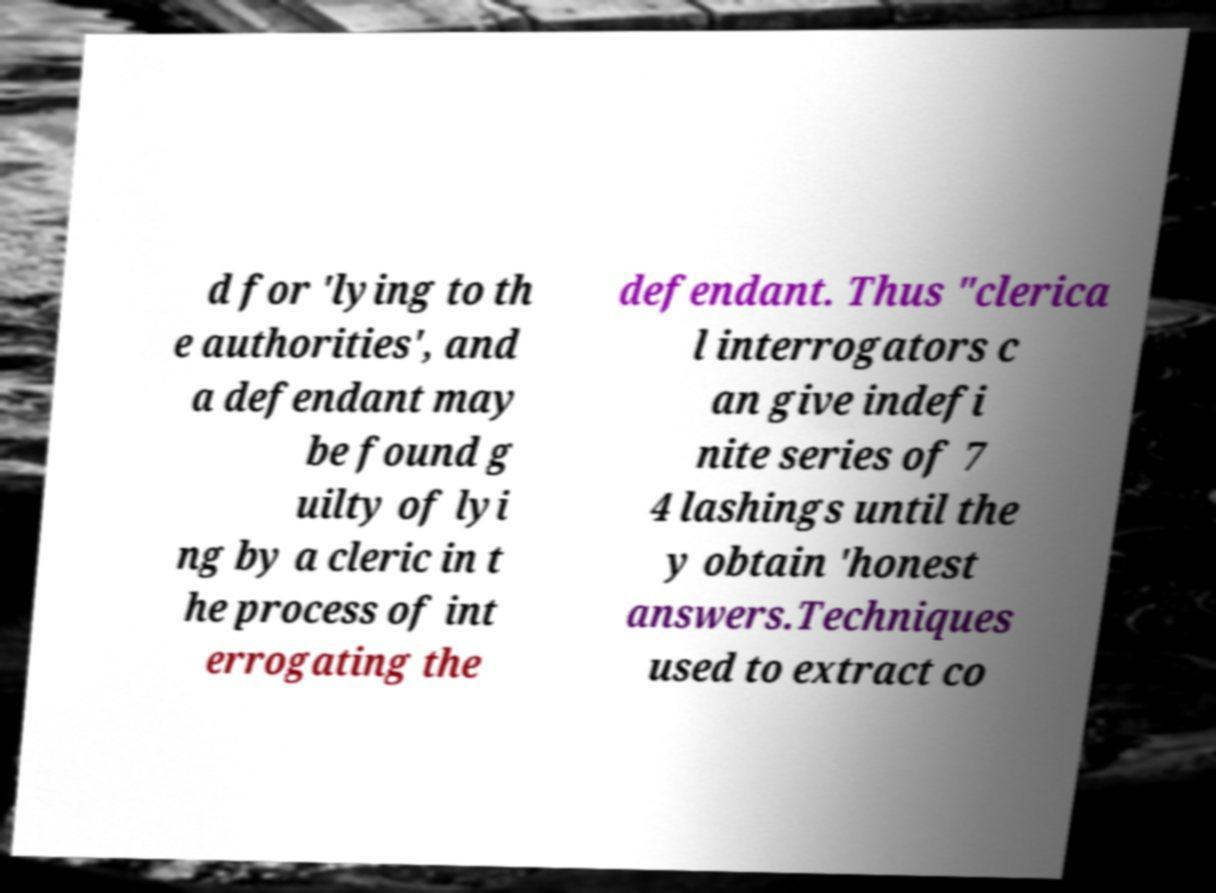Please identify and transcribe the text found in this image. d for 'lying to th e authorities', and a defendant may be found g uilty of lyi ng by a cleric in t he process of int errogating the defendant. Thus "clerica l interrogators c an give indefi nite series of 7 4 lashings until the y obtain 'honest answers.Techniques used to extract co 